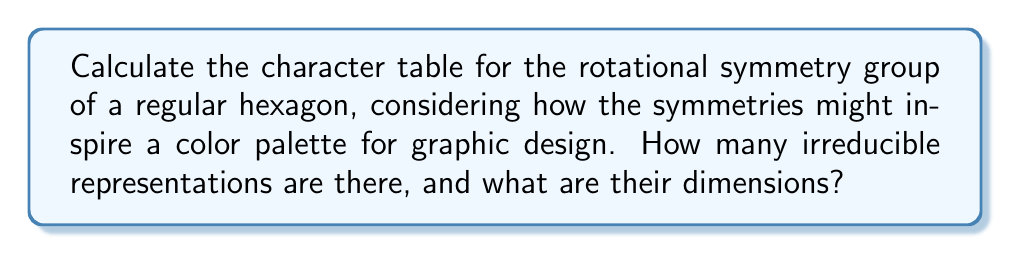What is the answer to this math problem? Let's approach this step-by-step:

1) First, we need to identify the group. The rotational symmetry group of a regular hexagon is isomorphic to the cyclic group $C_6$ of order 6.

2) The number of irreducible representations is equal to the number of conjugacy classes. In a cyclic group, each element forms its own conjugacy class. So, we have 6 conjugacy classes:
   $\{e\}, \{r\}, \{r^2\}, \{r^3\}, \{r^4\}, \{r^5\}$
   where $r$ represents a rotation by 60°.

3) For a cyclic group $C_n$, there are $n$ one-dimensional irreducible representations, given by:
   $$\chi_k(r^j) = e^{2\pi i k j / n}$$
   where $k = 0, 1, ..., n-1$ and $j = 0, 1, ..., n-1$.

4) For our $C_6$ group, we have:
   $$\chi_k(r^j) = e^{2\pi i k j / 6}$$

5) Let $\omega = e^{2\pi i / 6} = \frac{1}{2} + i\frac{\sqrt{3}}{2}$. Then our character table is:

   $$\begin{array}{c|cccccc}
    C_6 & e & r & r^2 & r^3 & r^4 & r^5 \\
   \hline
   \chi_0 & 1 & 1 & 1 & 1 & 1 & 1 \\
   \chi_1 & 1 & \omega & \omega^2 & \omega^3 & \omega^4 & \omega^5 \\
   \chi_2 & 1 & \omega^2 & \omega^4 & 1 & \omega^2 & \omega^4 \\
   \chi_3 & 1 & \omega^3 & 1 & \omega^3 & 1 & \omega^3 \\
   \chi_4 & 1 & \omega^4 & \omega^2 & 1 & \omega^4 & \omega^2 \\
   \chi_5 & 1 & \omega^5 & \omega^4 & \omega^3 & \omega^2 & \omega \\
   \end{array}$$

6) Note that $\omega^3 = -1$, $\omega^4 = \overline{\omega^2}$, and $\omega^5 = \overline{\omega}$.

This character table could inspire a color palette for graphic design, with each row potentially representing a different hue or shade, and the complex roots of unity inspiring color mixing ratios.
Answer: 6 irreducible representations, all 1-dimensional. 